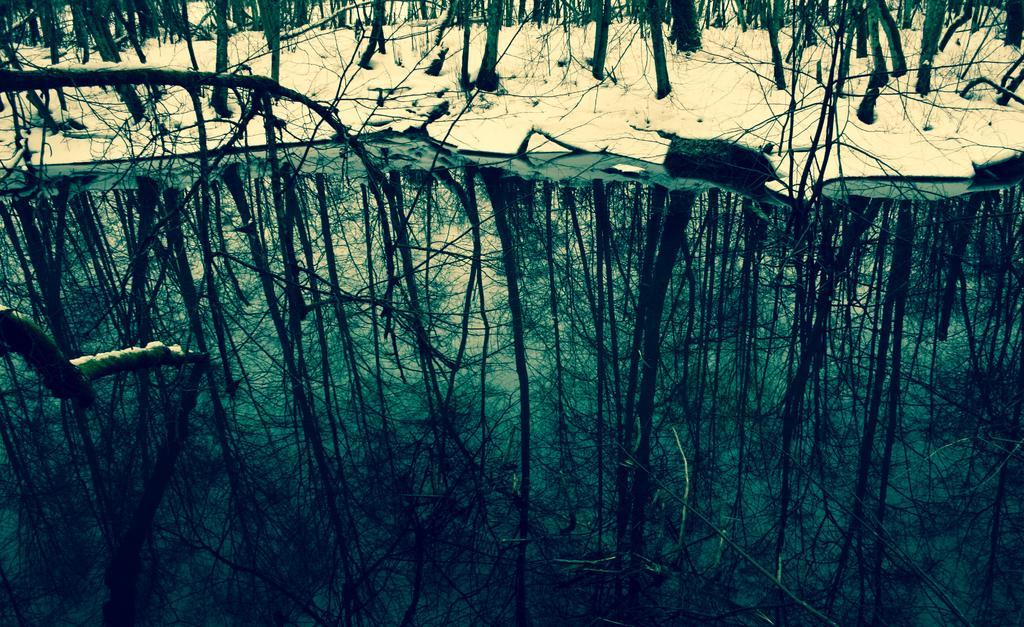In one or two sentences, can you explain what this image depicts? There is water. On the water there is reflection of trees. In the back there is snow and trees. 